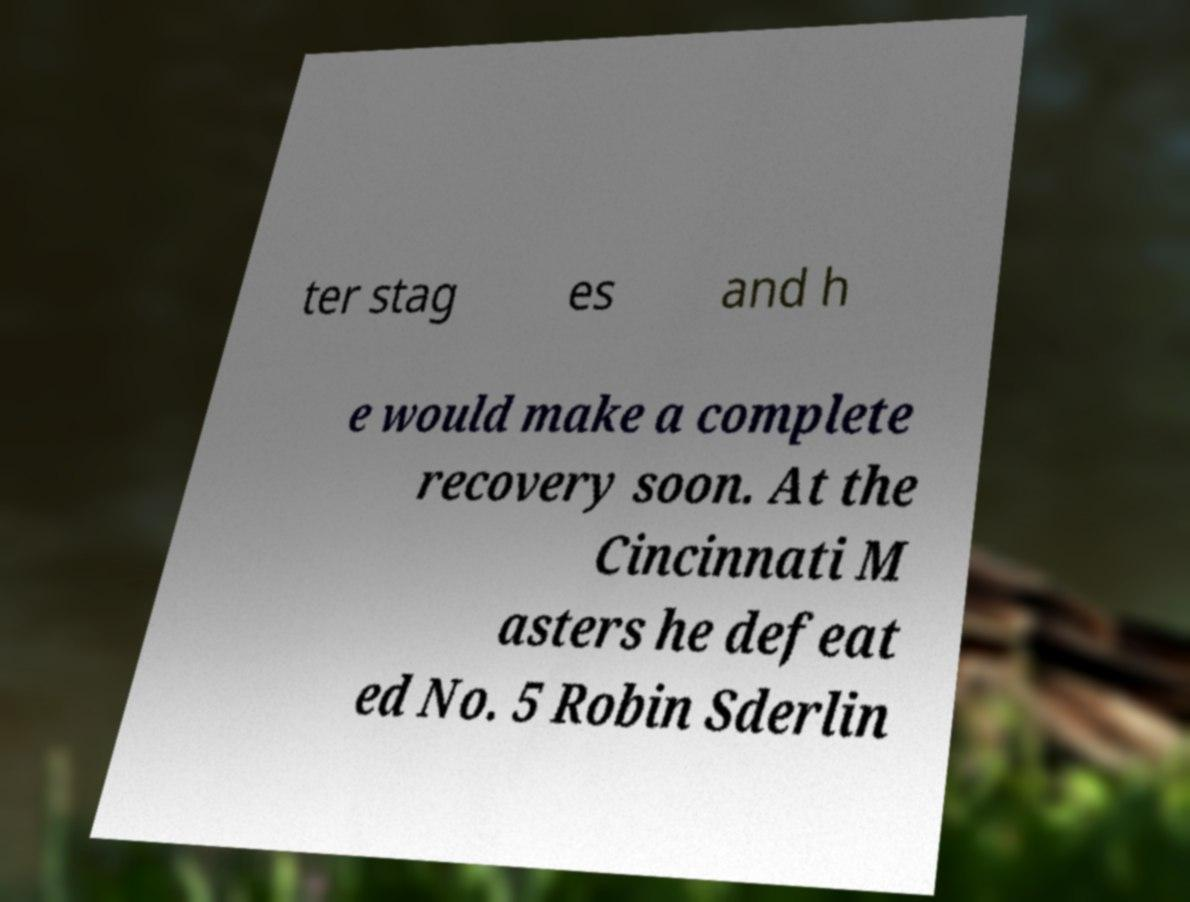Can you accurately transcribe the text from the provided image for me? ter stag es and h e would make a complete recovery soon. At the Cincinnati M asters he defeat ed No. 5 Robin Sderlin 